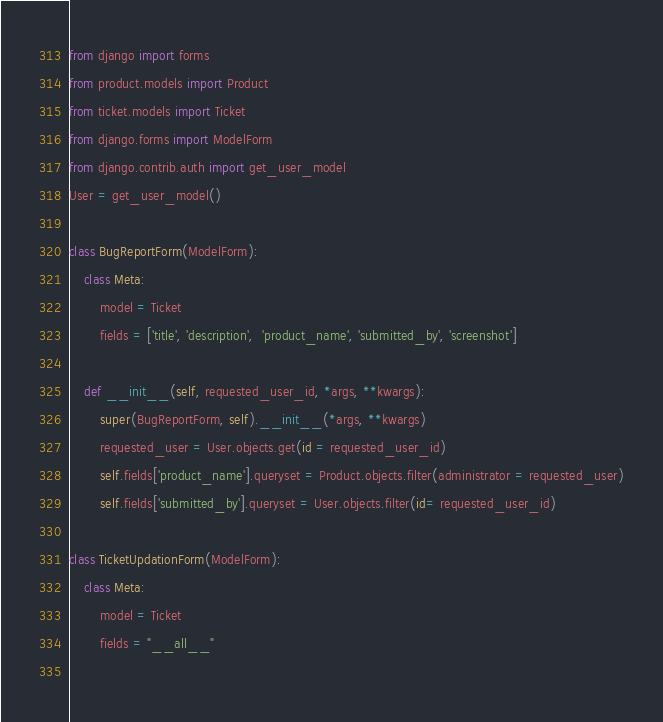<code> <loc_0><loc_0><loc_500><loc_500><_Python_>from django import forms
from product.models import Product
from ticket.models import Ticket
from django.forms import ModelForm
from django.contrib.auth import get_user_model
User = get_user_model()

class BugReportForm(ModelForm):
    class Meta:
        model = Ticket
        fields = ['title', 'description',  'product_name', 'submitted_by', 'screenshot']
    
    def __init__(self, requested_user_id, *args, **kwargs):
        super(BugReportForm, self).__init__(*args, **kwargs)
        requested_user = User.objects.get(id = requested_user_id)
        self.fields['product_name'].queryset = Product.objects.filter(administrator = requested_user)
        self.fields['submitted_by'].queryset = User.objects.filter(id= requested_user_id)

class TicketUpdationForm(ModelForm):
    class Meta:
        model = Ticket
        fields = "__all__"
    </code> 